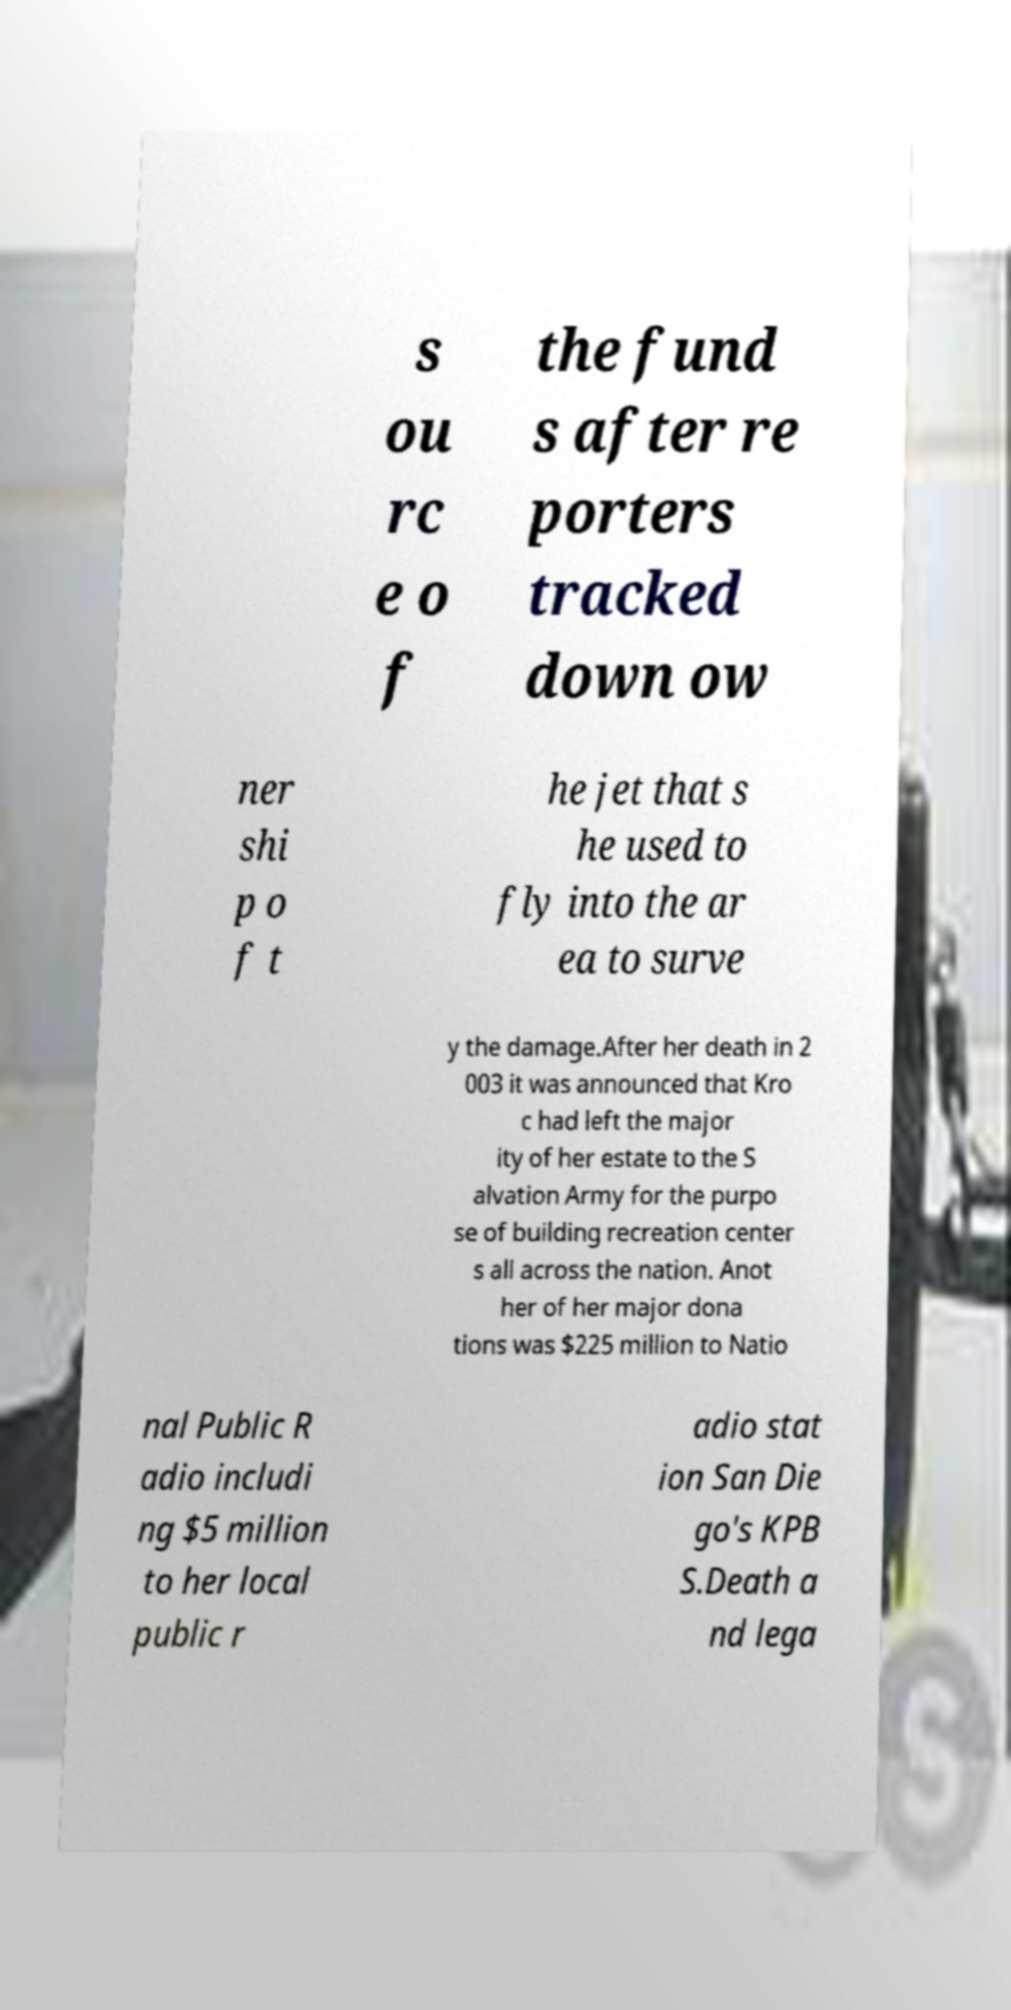I need the written content from this picture converted into text. Can you do that? s ou rc e o f the fund s after re porters tracked down ow ner shi p o f t he jet that s he used to fly into the ar ea to surve y the damage.After her death in 2 003 it was announced that Kro c had left the major ity of her estate to the S alvation Army for the purpo se of building recreation center s all across the nation. Anot her of her major dona tions was $225 million to Natio nal Public R adio includi ng $5 million to her local public r adio stat ion San Die go's KPB S.Death a nd lega 